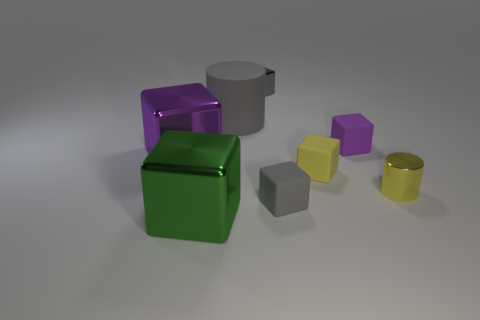Subtract all gray blocks. How many blocks are left? 4 Subtract all purple rubber blocks. How many blocks are left? 5 Subtract all yellow blocks. Subtract all cyan cylinders. How many blocks are left? 5 Add 2 gray rubber cylinders. How many objects exist? 10 Subtract all blocks. How many objects are left? 2 Subtract all gray metallic things. Subtract all large gray objects. How many objects are left? 6 Add 8 tiny purple blocks. How many tiny purple blocks are left? 9 Add 3 red shiny blocks. How many red shiny blocks exist? 3 Subtract 0 green cylinders. How many objects are left? 8 